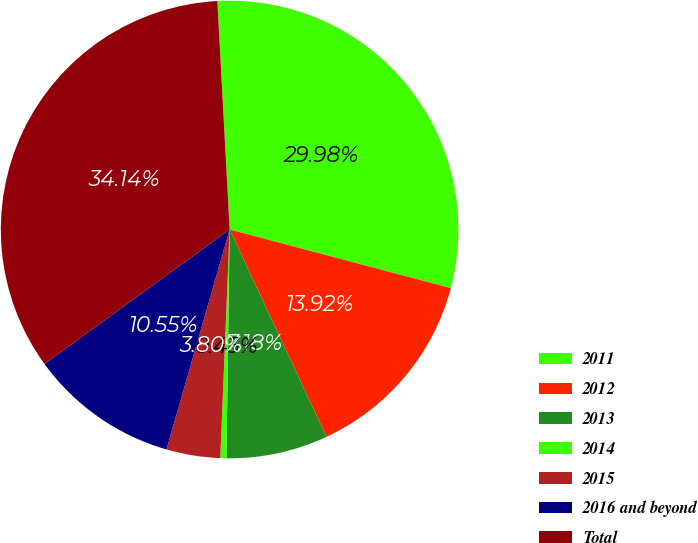Convert chart. <chart><loc_0><loc_0><loc_500><loc_500><pie_chart><fcel>2011<fcel>2012<fcel>2013<fcel>2014<fcel>2015<fcel>2016 and beyond<fcel>Total<nl><fcel>29.98%<fcel>13.92%<fcel>7.18%<fcel>0.43%<fcel>3.8%<fcel>10.55%<fcel>34.14%<nl></chart> 